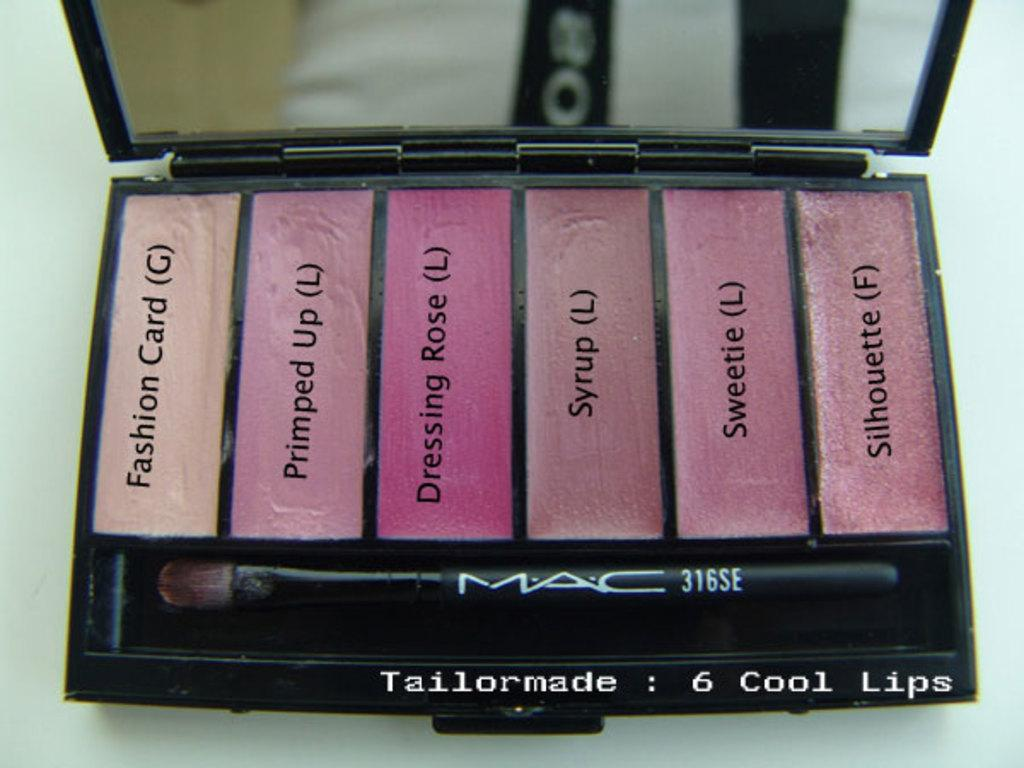What type of cosmetic product is visible in the image? There are colorful lipsticks in the image. How are the lipsticks stored in the image? The lipsticks are in a box in the image. What is another item visible in the image that might be used for personal grooming? There is a brush in the image. What might be used for checking one's appearance in the image? There is a mirror in the image. What type of sign can be seen in the image? There is no sign present in the image. What is the expected profit from selling the lipsticks in the image? There is no information about the profit or sales in the image. 